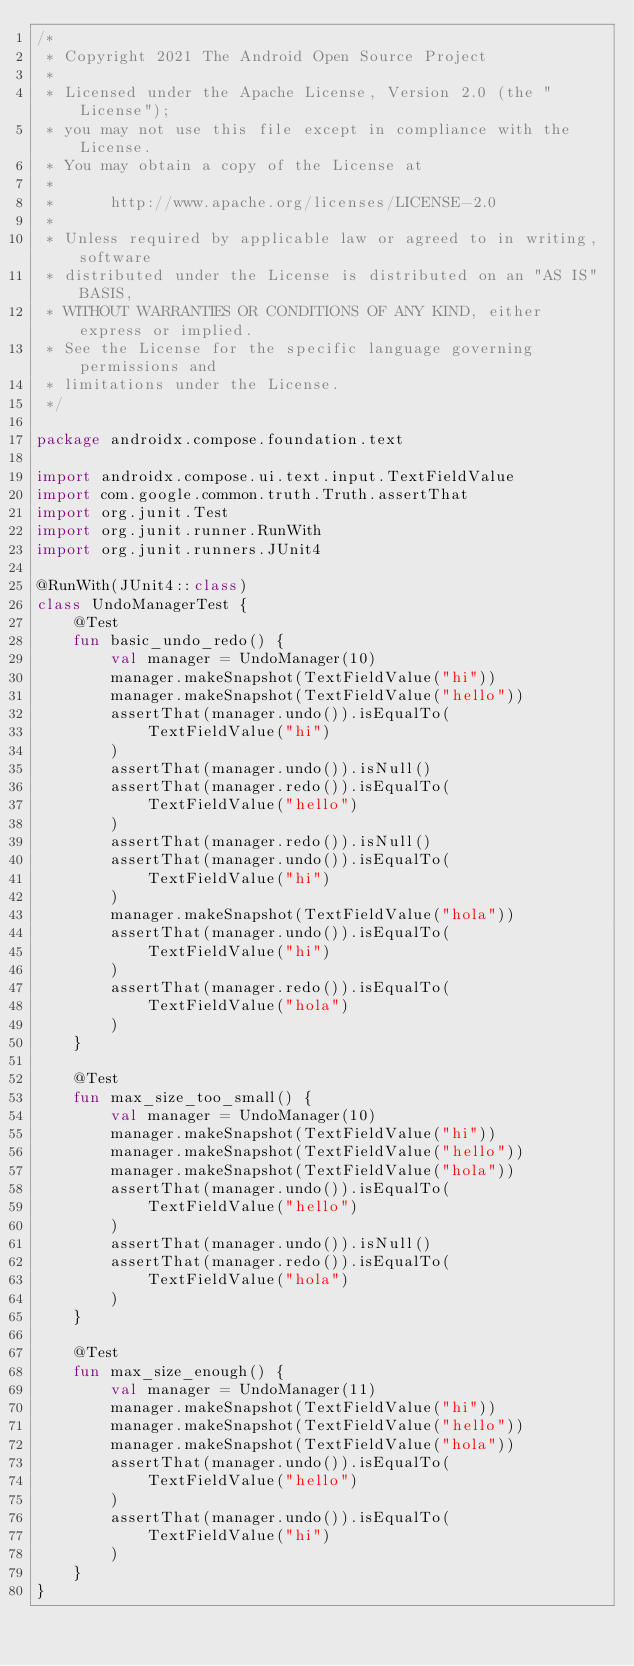Convert code to text. <code><loc_0><loc_0><loc_500><loc_500><_Kotlin_>/*
 * Copyright 2021 The Android Open Source Project
 *
 * Licensed under the Apache License, Version 2.0 (the "License");
 * you may not use this file except in compliance with the License.
 * You may obtain a copy of the License at
 *
 *      http://www.apache.org/licenses/LICENSE-2.0
 *
 * Unless required by applicable law or agreed to in writing, software
 * distributed under the License is distributed on an "AS IS" BASIS,
 * WITHOUT WARRANTIES OR CONDITIONS OF ANY KIND, either express or implied.
 * See the License for the specific language governing permissions and
 * limitations under the License.
 */

package androidx.compose.foundation.text

import androidx.compose.ui.text.input.TextFieldValue
import com.google.common.truth.Truth.assertThat
import org.junit.Test
import org.junit.runner.RunWith
import org.junit.runners.JUnit4

@RunWith(JUnit4::class)
class UndoManagerTest {
    @Test
    fun basic_undo_redo() {
        val manager = UndoManager(10)
        manager.makeSnapshot(TextFieldValue("hi"))
        manager.makeSnapshot(TextFieldValue("hello"))
        assertThat(manager.undo()).isEqualTo(
            TextFieldValue("hi")
        )
        assertThat(manager.undo()).isNull()
        assertThat(manager.redo()).isEqualTo(
            TextFieldValue("hello")
        )
        assertThat(manager.redo()).isNull()
        assertThat(manager.undo()).isEqualTo(
            TextFieldValue("hi")
        )
        manager.makeSnapshot(TextFieldValue("hola"))
        assertThat(manager.undo()).isEqualTo(
            TextFieldValue("hi")
        )
        assertThat(manager.redo()).isEqualTo(
            TextFieldValue("hola")
        )
    }

    @Test
    fun max_size_too_small() {
        val manager = UndoManager(10)
        manager.makeSnapshot(TextFieldValue("hi"))
        manager.makeSnapshot(TextFieldValue("hello"))
        manager.makeSnapshot(TextFieldValue("hola"))
        assertThat(manager.undo()).isEqualTo(
            TextFieldValue("hello")
        )
        assertThat(manager.undo()).isNull()
        assertThat(manager.redo()).isEqualTo(
            TextFieldValue("hola")
        )
    }

    @Test
    fun max_size_enough() {
        val manager = UndoManager(11)
        manager.makeSnapshot(TextFieldValue("hi"))
        manager.makeSnapshot(TextFieldValue("hello"))
        manager.makeSnapshot(TextFieldValue("hola"))
        assertThat(manager.undo()).isEqualTo(
            TextFieldValue("hello")
        )
        assertThat(manager.undo()).isEqualTo(
            TextFieldValue("hi")
        )
    }
}</code> 